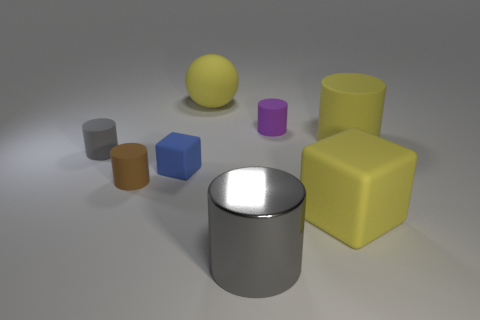How many other big cubes have the same material as the big cube?
Offer a terse response. 0. What number of purple cylinders are the same size as the blue cube?
Your answer should be very brief. 1. The gray object to the left of the big cylinder that is in front of the matte cube to the right of the large yellow ball is made of what material?
Provide a succinct answer. Rubber. How many things are either yellow matte things or brown matte cylinders?
Keep it short and to the point. 4. Is there anything else that is made of the same material as the yellow block?
Offer a terse response. Yes. There is a blue matte object; what shape is it?
Give a very brief answer. Cube. What shape is the big matte object behind the big thing that is on the right side of the large yellow matte block?
Make the answer very short. Sphere. Do the tiny cylinder on the right side of the ball and the yellow sphere have the same material?
Ensure brevity in your answer.  Yes. What number of blue objects are either big shiny cylinders or matte cubes?
Keep it short and to the point. 1. Is there another cylinder that has the same color as the big rubber cylinder?
Your answer should be compact. No. 